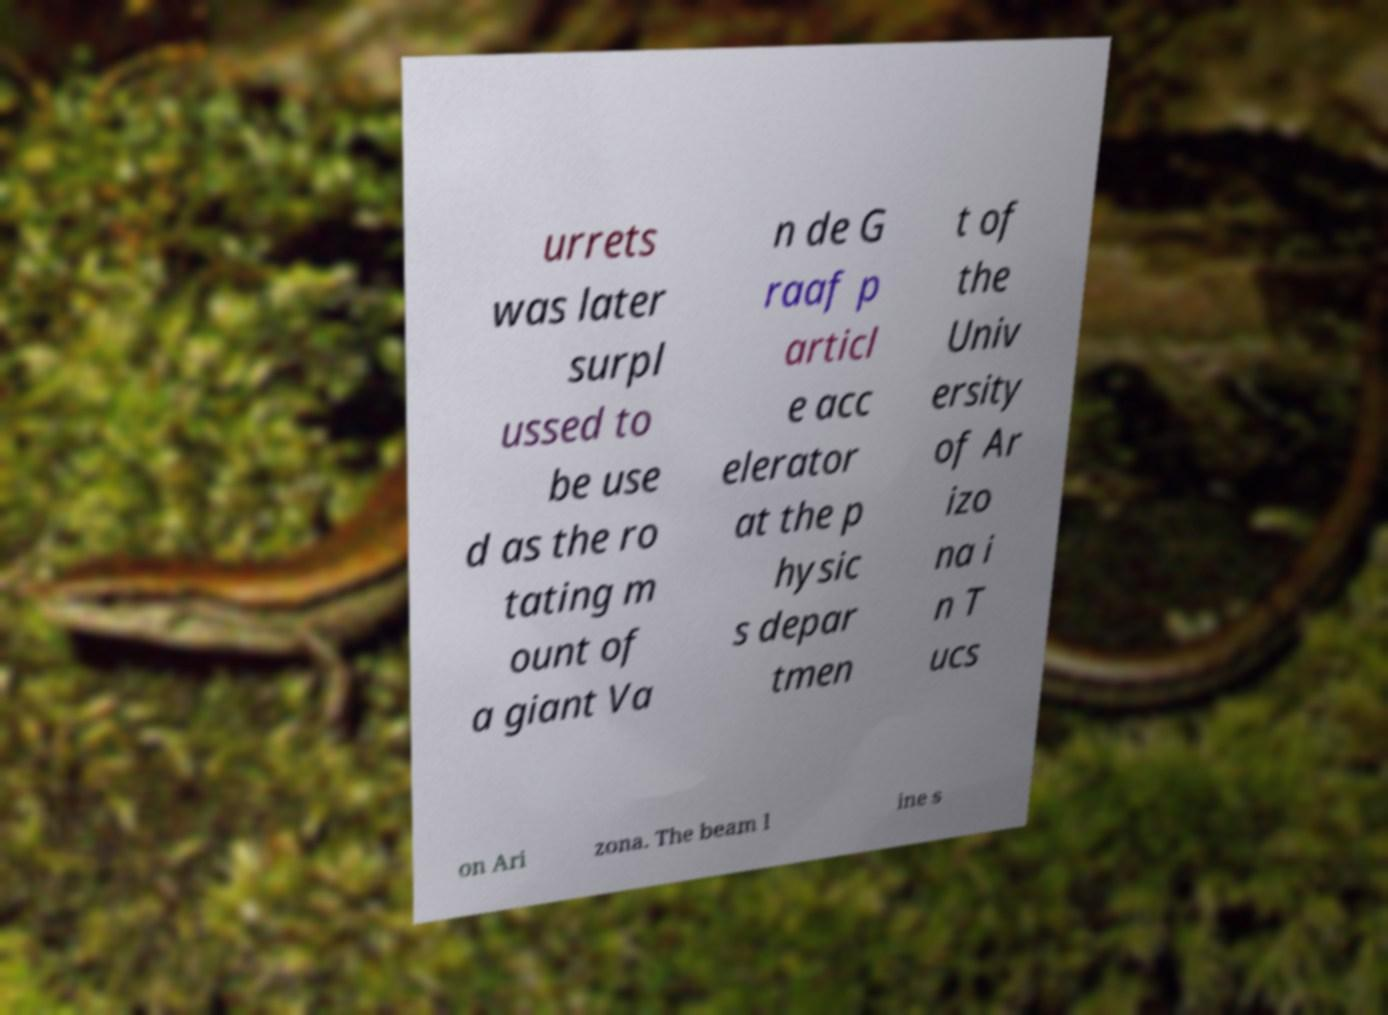I need the written content from this picture converted into text. Can you do that? urrets was later surpl ussed to be use d as the ro tating m ount of a giant Va n de G raaf p articl e acc elerator at the p hysic s depar tmen t of the Univ ersity of Ar izo na i n T ucs on Ari zona. The beam l ine s 